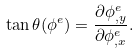Convert formula to latex. <formula><loc_0><loc_0><loc_500><loc_500>\tan \theta ( { \phi } ^ { e } ) = \frac { \partial \phi _ { , y } ^ { e } } { \partial \phi _ { , x } ^ { e } } .</formula> 